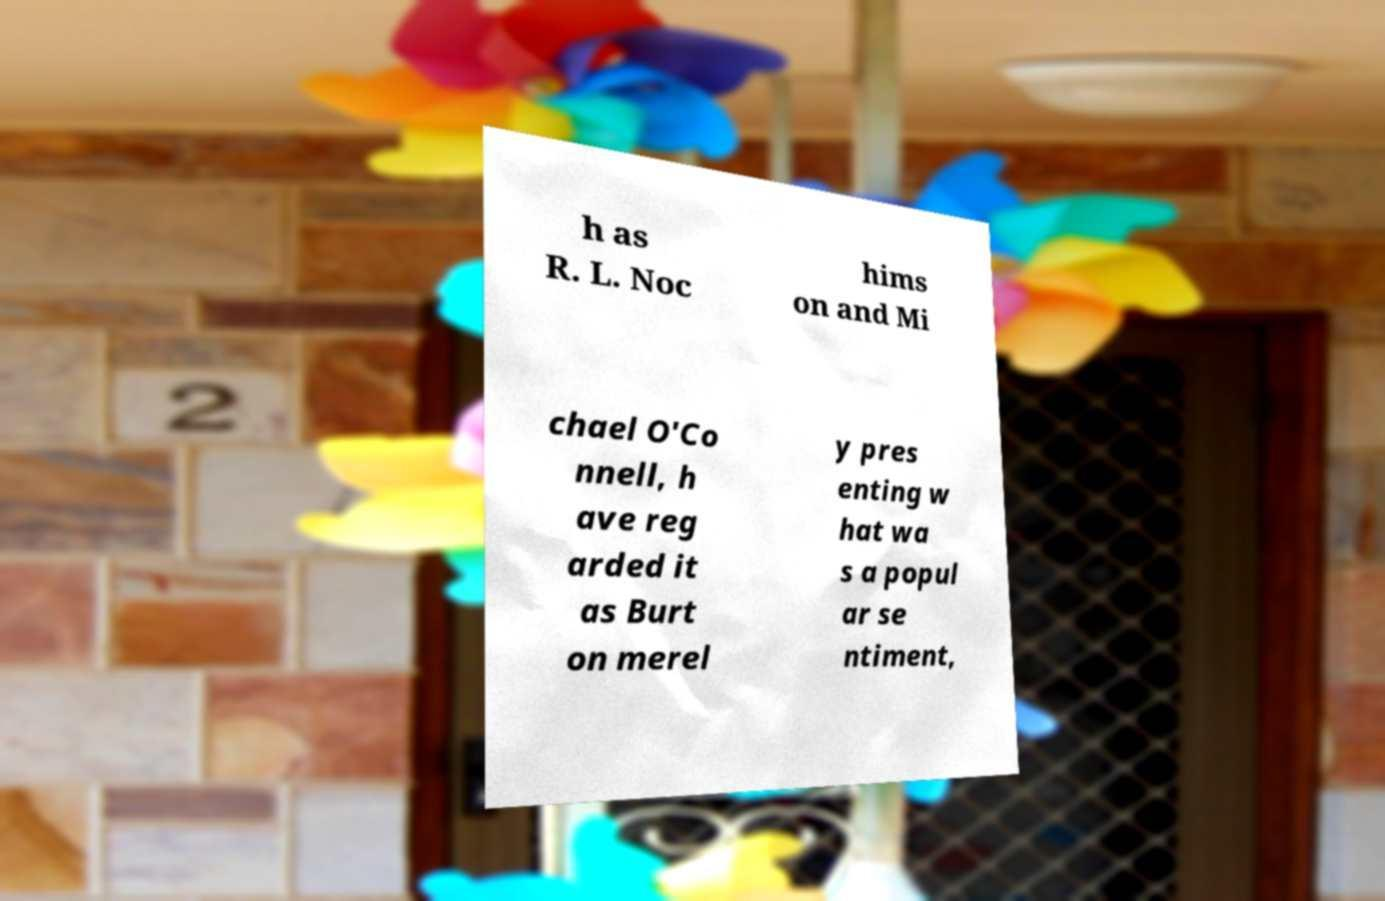Please read and relay the text visible in this image. What does it say? h as R. L. Noc hims on and Mi chael O'Co nnell, h ave reg arded it as Burt on merel y pres enting w hat wa s a popul ar se ntiment, 